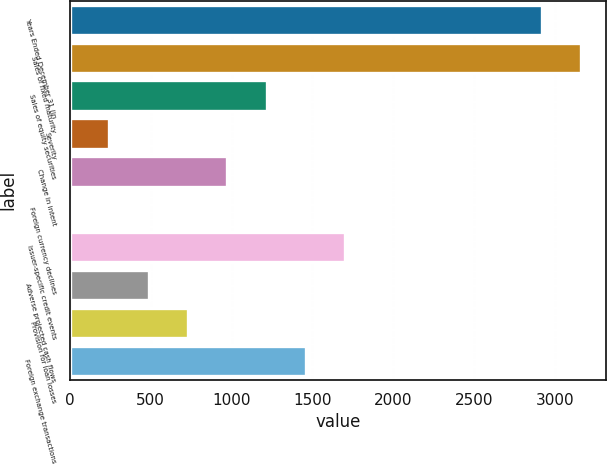<chart> <loc_0><loc_0><loc_500><loc_500><bar_chart><fcel>Years Ended December 31 (in<fcel>Sales of fixed maturity<fcel>Sales of equity securities<fcel>Severity<fcel>Change in intent<fcel>Foreign currency declines<fcel>Issuer-specific credit events<fcel>Adverse projected cash flows<fcel>Provision for loan losses<fcel>Foreign exchange transactions<nl><fcel>2918.2<fcel>3161.3<fcel>1216.5<fcel>244.1<fcel>973.4<fcel>1<fcel>1702.7<fcel>487.2<fcel>730.3<fcel>1459.6<nl></chart> 